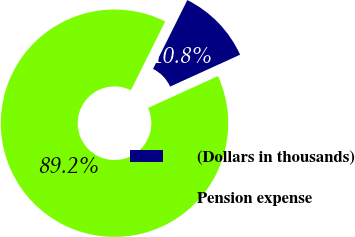Convert chart. <chart><loc_0><loc_0><loc_500><loc_500><pie_chart><fcel>(Dollars in thousands)<fcel>Pension expense<nl><fcel>10.84%<fcel>89.16%<nl></chart> 